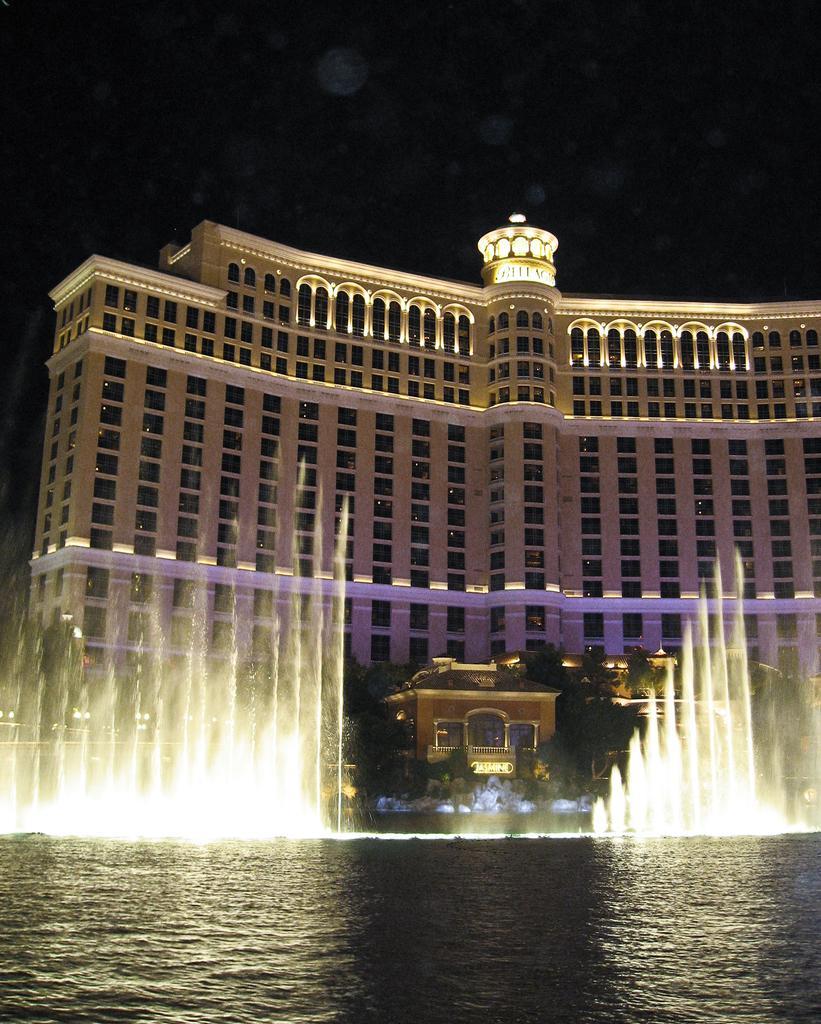In one or two sentences, can you explain what this image depicts? In this image at the bottom, there are water, fountain, waves, trees. In the middle there are buildings, windows, steeple, lights, trees, street lights, sky. 